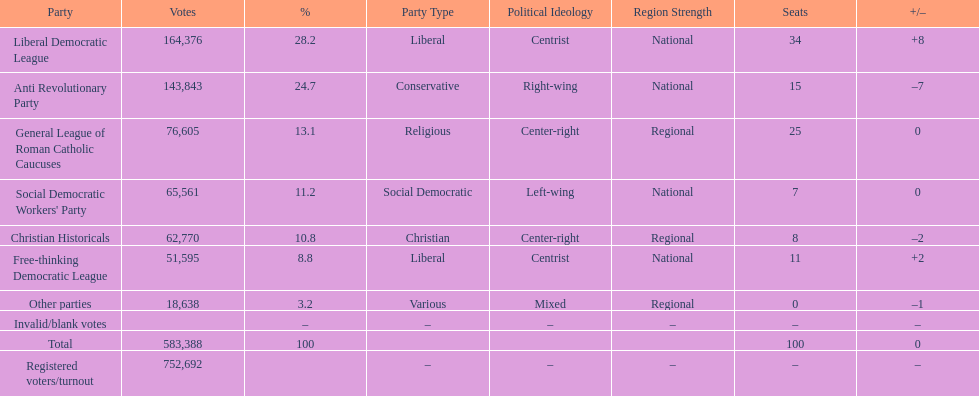How many more votes did the liberal democratic league win over the free-thinking democratic league? 112,781. 